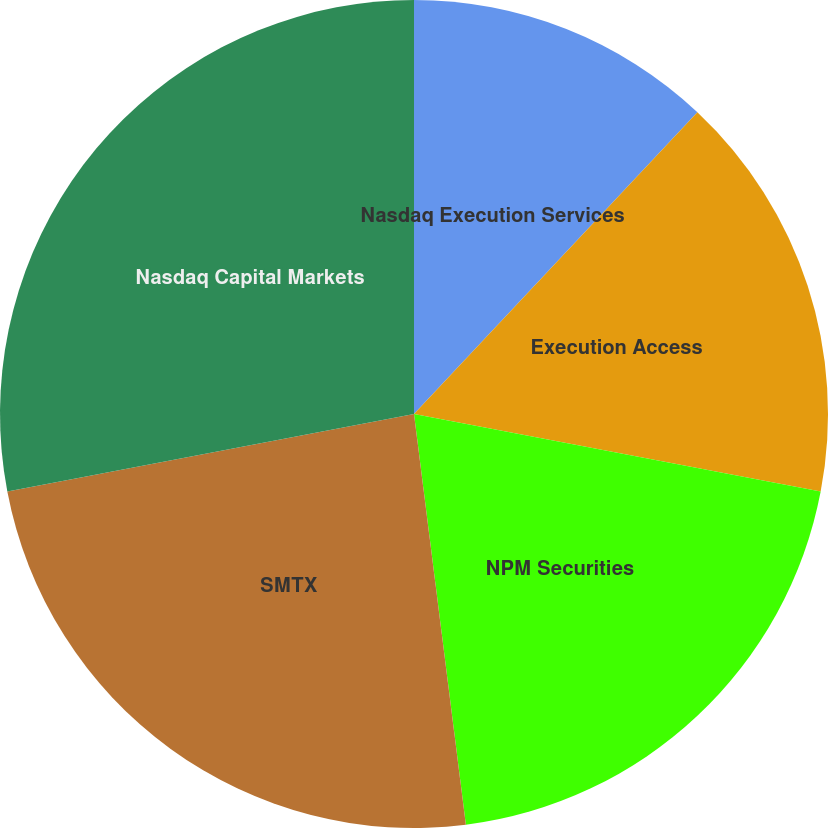Convert chart. <chart><loc_0><loc_0><loc_500><loc_500><pie_chart><fcel>Nasdaq Execution Services<fcel>Execution Access<fcel>NPM Securities<fcel>SMTX<fcel>Nasdaq Capital Markets<nl><fcel>12.0%<fcel>16.0%<fcel>20.0%<fcel>24.0%<fcel>28.0%<nl></chart> 